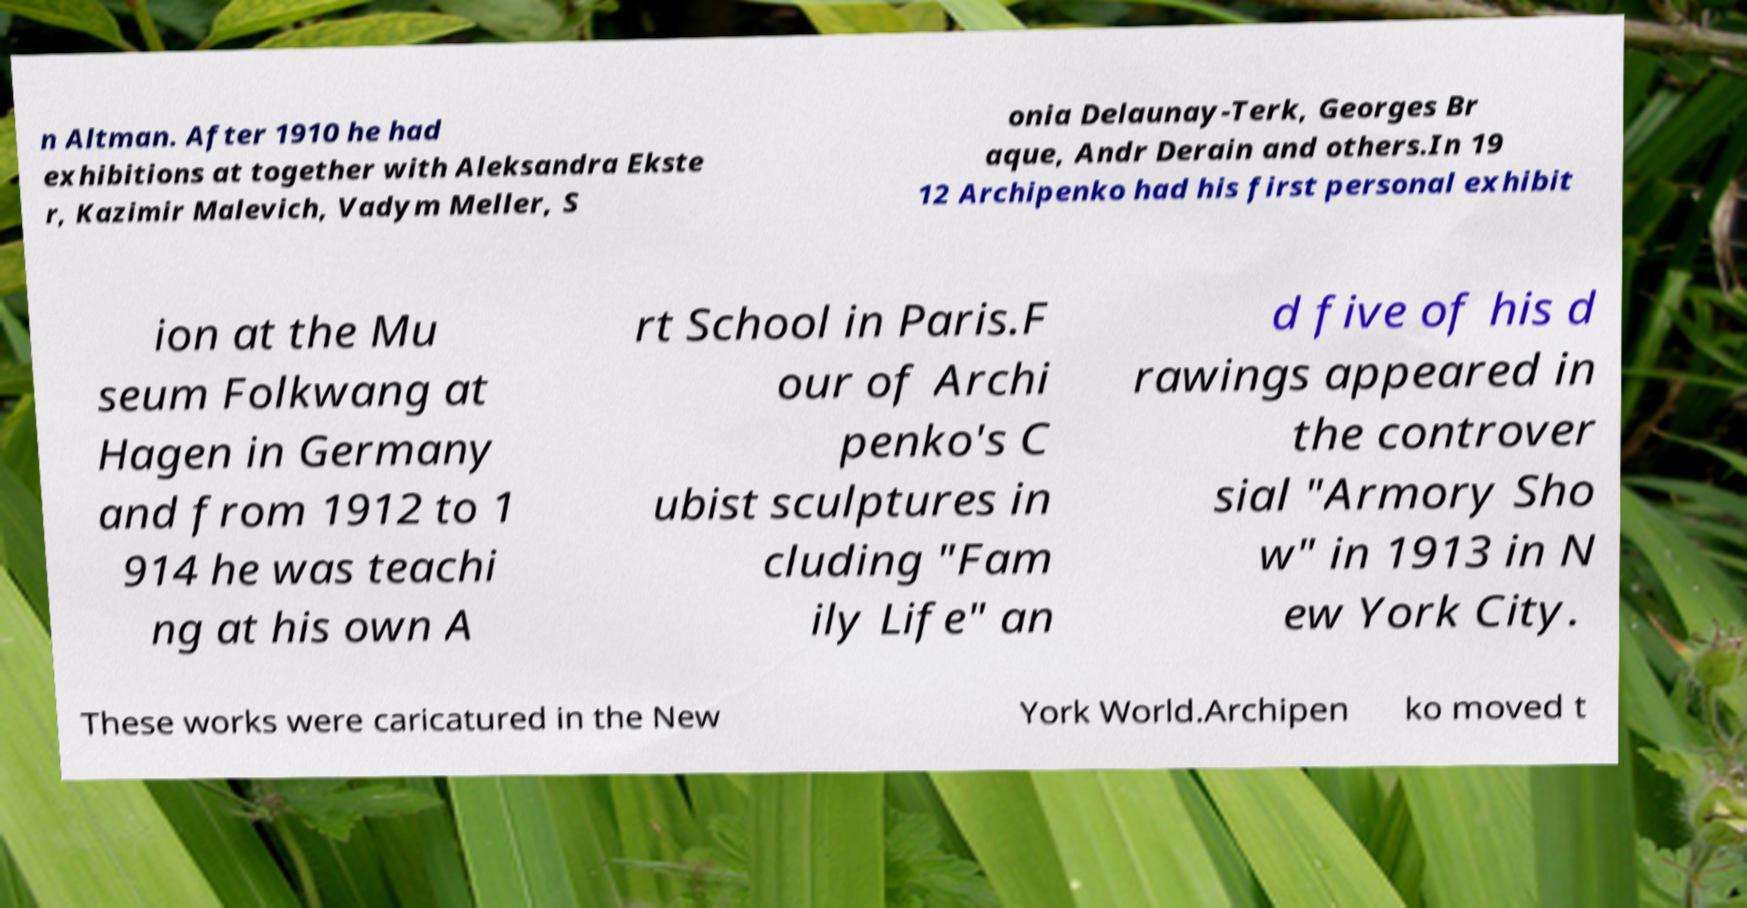For documentation purposes, I need the text within this image transcribed. Could you provide that? n Altman. After 1910 he had exhibitions at together with Aleksandra Ekste r, Kazimir Malevich, Vadym Meller, S onia Delaunay-Terk, Georges Br aque, Andr Derain and others.In 19 12 Archipenko had his first personal exhibit ion at the Mu seum Folkwang at Hagen in Germany and from 1912 to 1 914 he was teachi ng at his own A rt School in Paris.F our of Archi penko's C ubist sculptures in cluding "Fam ily Life" an d five of his d rawings appeared in the controver sial "Armory Sho w" in 1913 in N ew York City. These works were caricatured in the New York World.Archipen ko moved t 